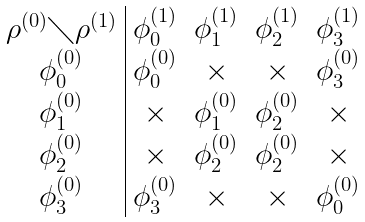Convert formula to latex. <formula><loc_0><loc_0><loc_500><loc_500>\begin{array} { c | c c c c } \rho ^ { ( 0 ) } \diagdown \rho ^ { ( 1 ) } & \phi _ { 0 } ^ { ( 1 ) } & \phi ^ { ( 1 ) } _ { 1 } & \phi ^ { ( 1 ) } _ { 2 } & \phi ^ { ( 1 ) } _ { 3 } \\ \phi _ { 0 } ^ { ( 0 ) } & \phi ^ { ( 0 ) } _ { 0 } & \times & \times & \phi ^ { ( 0 ) } _ { 3 } \\ \phi _ { 1 } ^ { ( 0 ) } & \times & \phi ^ { ( 0 ) } _ { 1 } & \phi ^ { ( 0 ) } _ { 2 } & \times \\ \phi _ { 2 } ^ { ( 0 ) } & \times & \phi ^ { ( 0 ) } _ { 2 } & \phi ^ { ( 0 ) } _ { 2 } & \times \\ \phi _ { 3 } ^ { ( 0 ) } & \phi ^ { ( 0 ) } _ { 3 } & \times & \times & \phi ^ { ( 0 ) } _ { 0 } \end{array}</formula> 